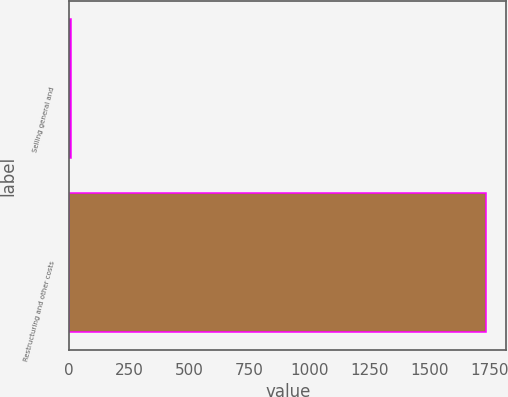<chart> <loc_0><loc_0><loc_500><loc_500><bar_chart><fcel>Selling general and<fcel>Restructuring and other costs<nl><fcel>10<fcel>1732.8<nl></chart> 